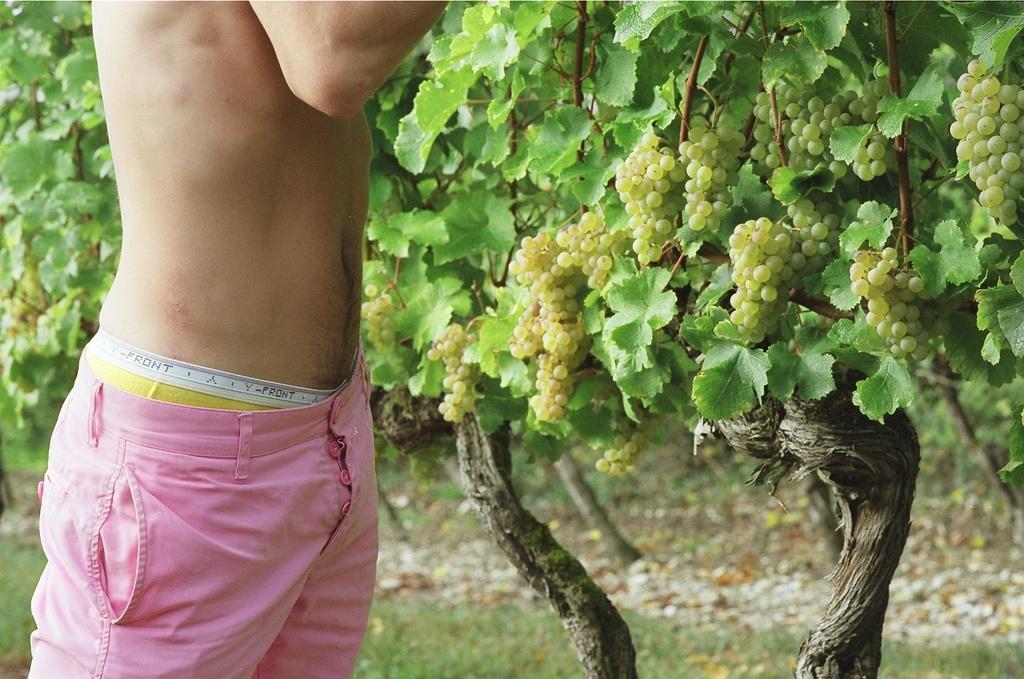In one or two sentences, can you explain what this image depicts? In this image there is one person standing at left side of this image. There is a grape tree in the background and as we can see there are some grapes at right side of this image. 